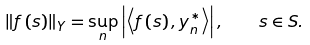Convert formula to latex. <formula><loc_0><loc_0><loc_500><loc_500>\left \| f \left ( s \right ) \right \| _ { Y } = \sup _ { n } \left | \left \langle f \left ( s \right ) , y _ { n } ^ { \ast } \right \rangle \right | , \quad s \in S .</formula> 